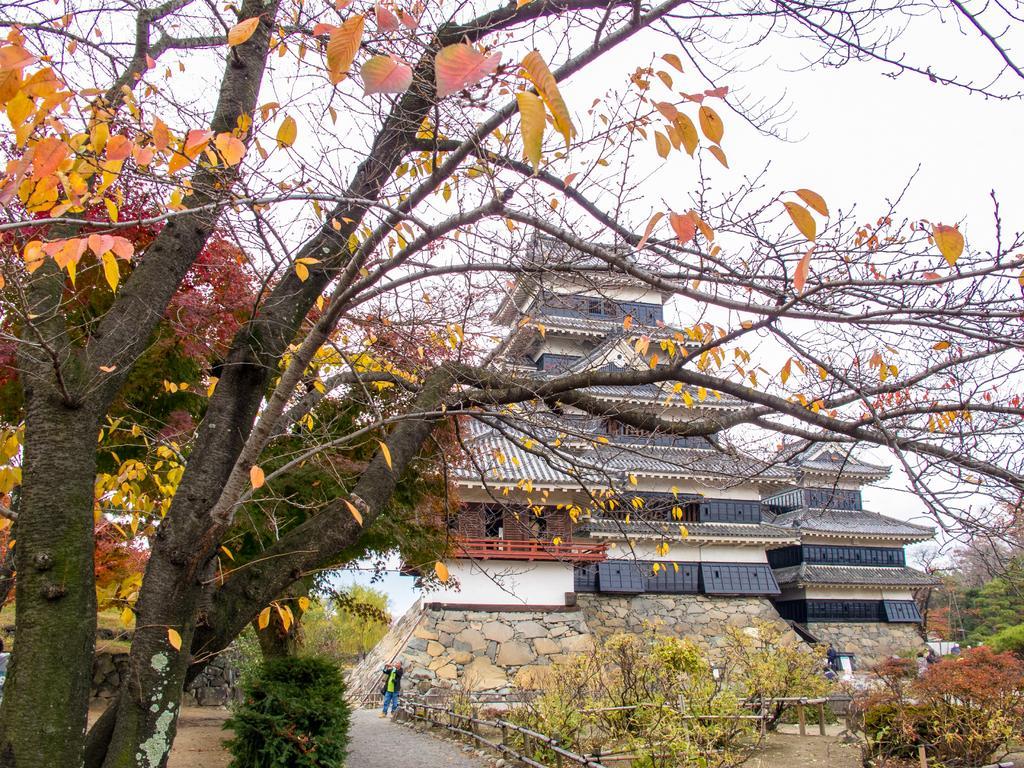Could you give a brief overview of what you see in this image? In this image on the left side we can see a tree. In the background we can see buildings, few persons, windows, fences, plants, trees and sky. 